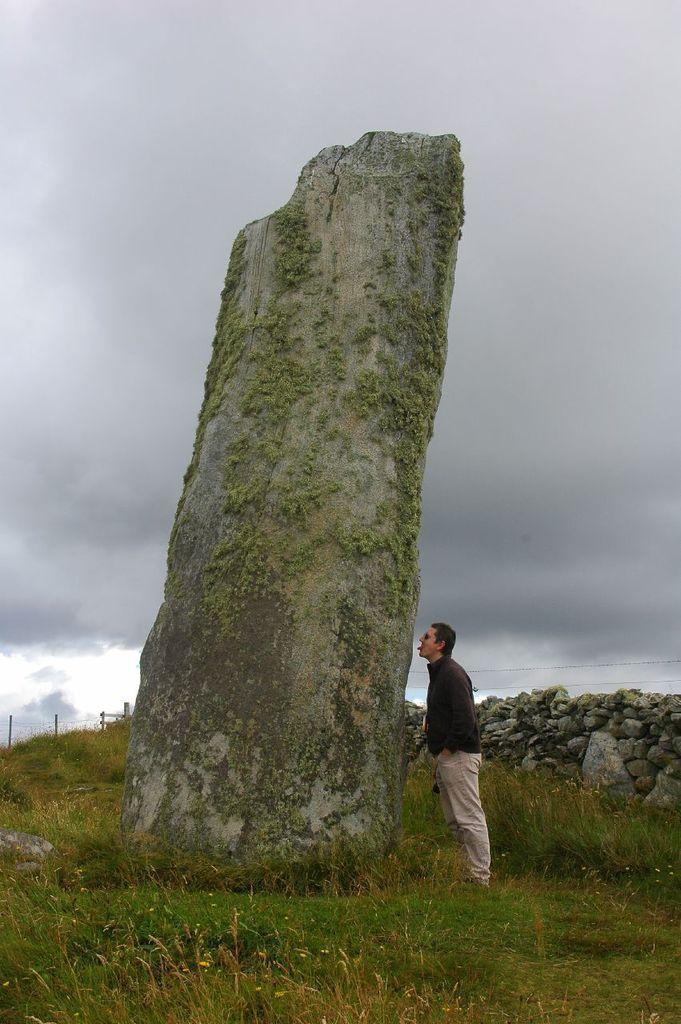In one or two sentences, can you explain what this image depicts? In the picture I can see a person standing on the grass, here I can see a big rock, I can see stone wall, the grass, fence,0 wires and the cloudy sky in the background. 